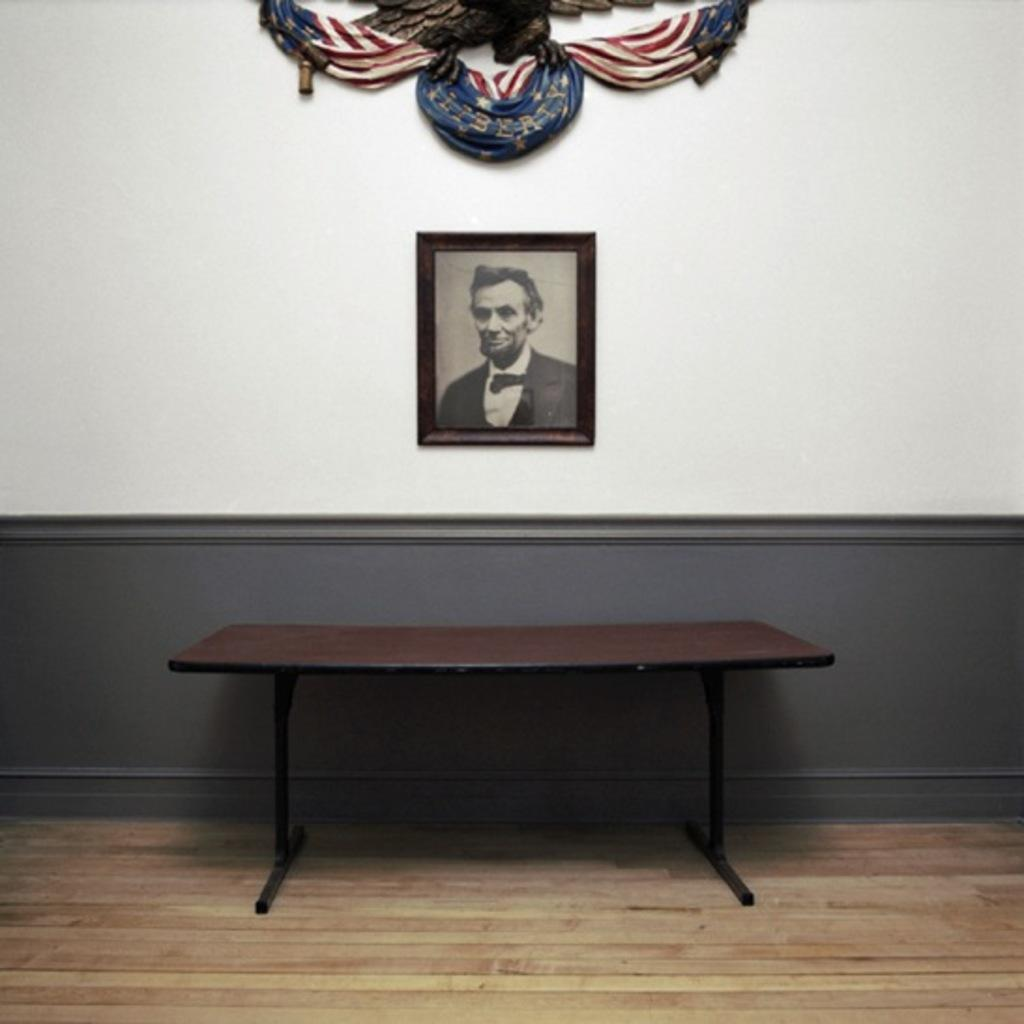What piece of furniture is present in the image? There is a table in the image. What is attached to the wall in the image? There is a frame attached to the wall in the image. What type of window treatment is present in the image? There is a curtain associated with the wall in the image. What caused the frame to fall off the wall in the image? There is no indication in the image that the frame has fallen off the wall, nor is there any information about what might have caused it to fall. 